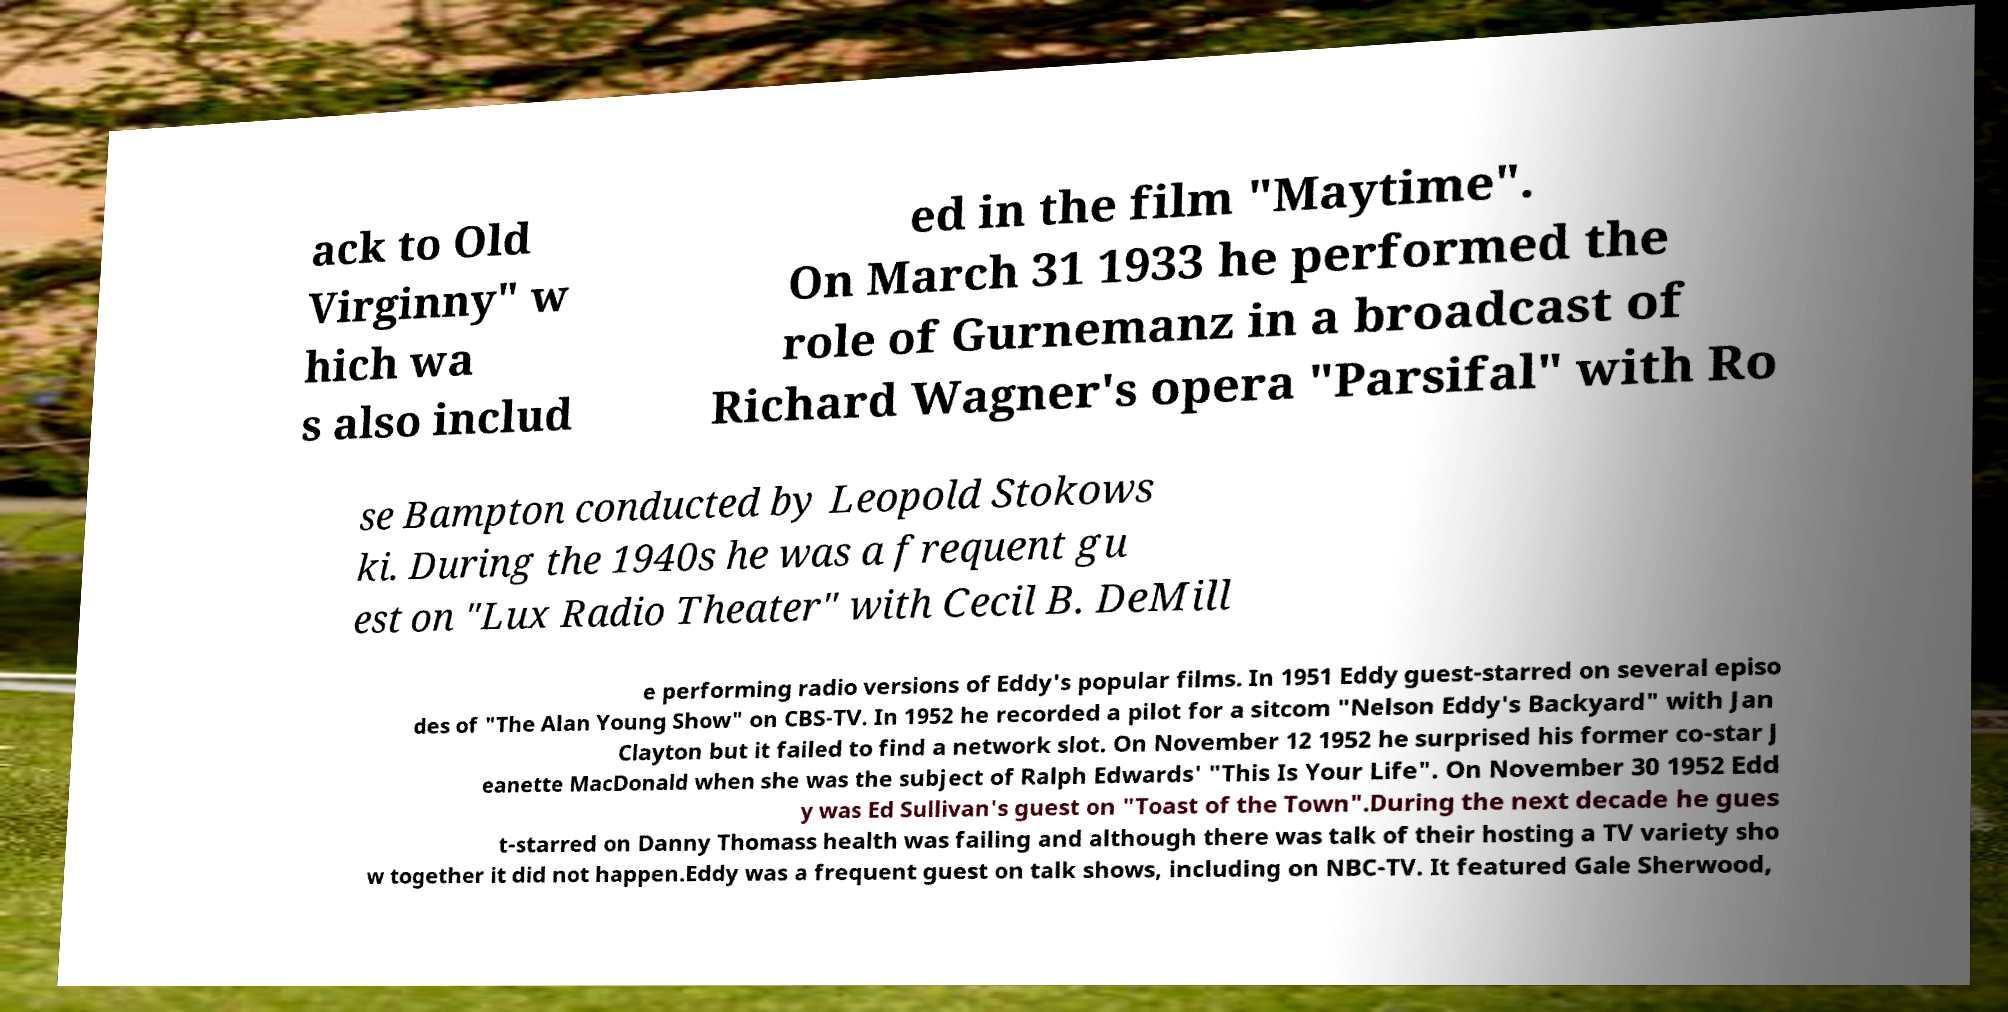Can you read and provide the text displayed in the image?This photo seems to have some interesting text. Can you extract and type it out for me? ack to Old Virginny" w hich wa s also includ ed in the film "Maytime". On March 31 1933 he performed the role of Gurnemanz in a broadcast of Richard Wagner's opera "Parsifal" with Ro se Bampton conducted by Leopold Stokows ki. During the 1940s he was a frequent gu est on "Lux Radio Theater" with Cecil B. DeMill e performing radio versions of Eddy's popular films. In 1951 Eddy guest-starred on several episo des of "The Alan Young Show" on CBS-TV. In 1952 he recorded a pilot for a sitcom "Nelson Eddy's Backyard" with Jan Clayton but it failed to find a network slot. On November 12 1952 he surprised his former co-star J eanette MacDonald when she was the subject of Ralph Edwards' "This Is Your Life". On November 30 1952 Edd y was Ed Sullivan's guest on "Toast of the Town".During the next decade he gues t-starred on Danny Thomass health was failing and although there was talk of their hosting a TV variety sho w together it did not happen.Eddy was a frequent guest on talk shows, including on NBC-TV. It featured Gale Sherwood, 